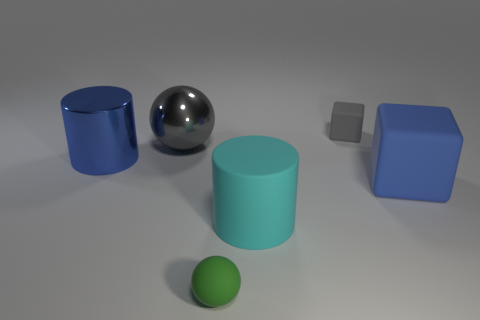Add 4 shiny cylinders. How many objects exist? 10 Subtract all cylinders. How many objects are left? 4 Subtract 0 yellow spheres. How many objects are left? 6 Subtract all tiny gray metal things. Subtract all metallic balls. How many objects are left? 5 Add 3 gray spheres. How many gray spheres are left? 4 Add 5 big red shiny cylinders. How many big red shiny cylinders exist? 5 